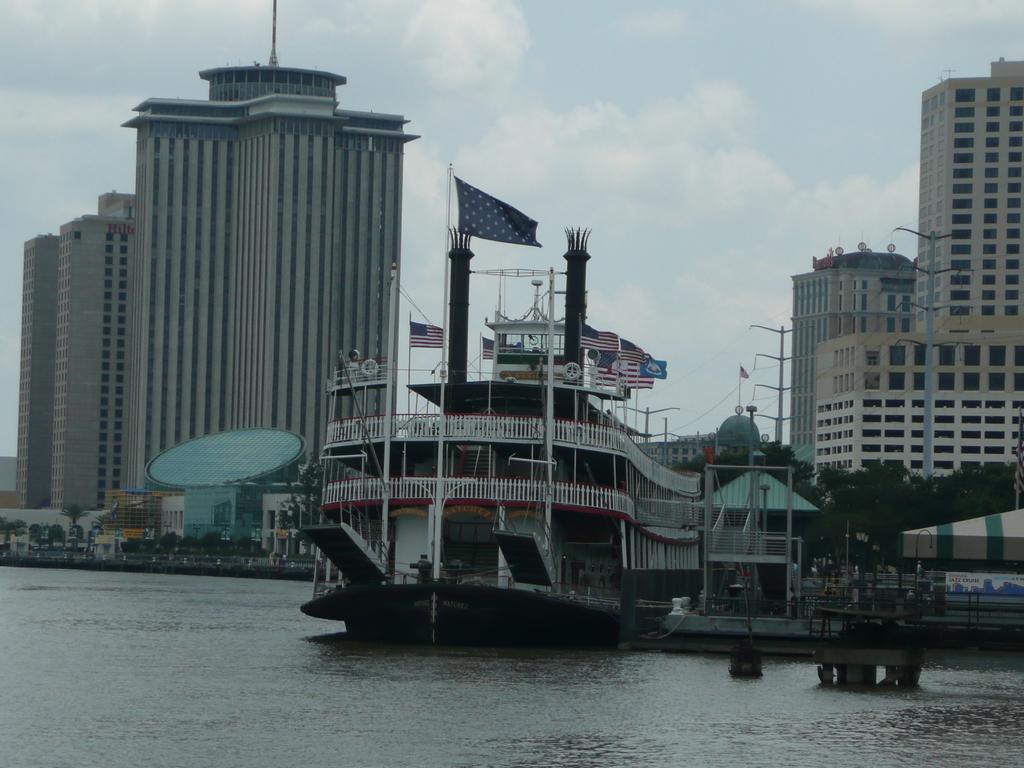Describe this image in one or two sentences. In the middle of the image we can see a ship on the water and we can see flags, in the background we can find few buildings, poles, trees and clouds. 